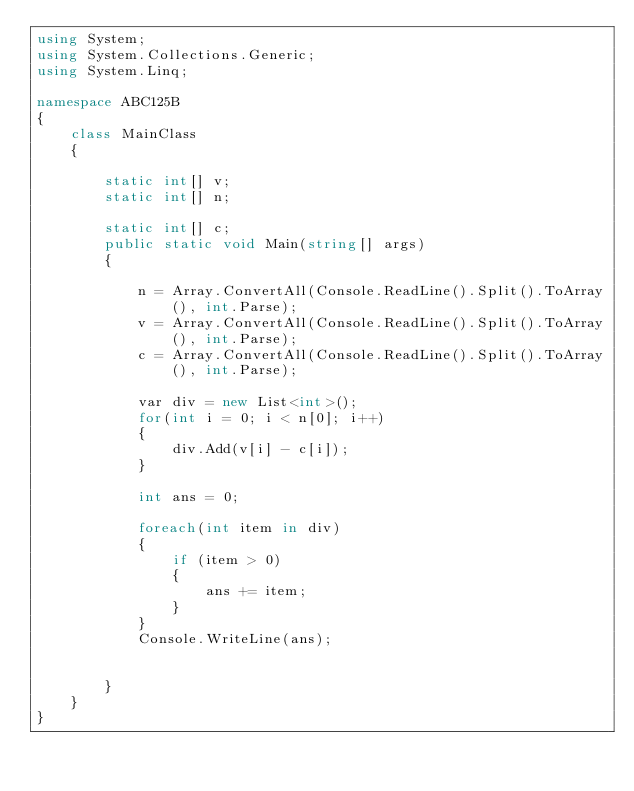<code> <loc_0><loc_0><loc_500><loc_500><_C#_>using System;
using System.Collections.Generic;
using System.Linq;

namespace ABC125B
{
    class MainClass
    {

        static int[] v;
        static int[] n;

        static int[] c;
        public static void Main(string[] args)
        {

            n = Array.ConvertAll(Console.ReadLine().Split().ToArray(), int.Parse);
            v = Array.ConvertAll(Console.ReadLine().Split().ToArray(), int.Parse);
            c = Array.ConvertAll(Console.ReadLine().Split().ToArray(), int.Parse);

            var div = new List<int>();
            for(int i = 0; i < n[0]; i++)
            {
                div.Add(v[i] - c[i]);
            }

            int ans = 0;

            foreach(int item in div)
            {
                if (item > 0)
                {
                    ans += item;
                }
            }
            Console.WriteLine(ans);


        }
    }
}
</code> 